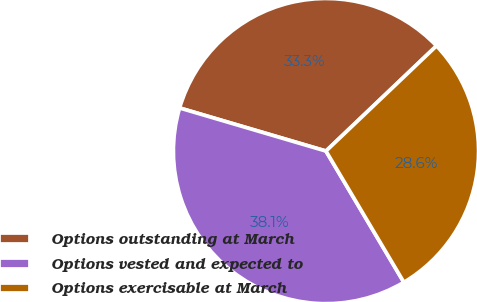Convert chart to OTSL. <chart><loc_0><loc_0><loc_500><loc_500><pie_chart><fcel>Options outstanding at March<fcel>Options vested and expected to<fcel>Options exercisable at March<nl><fcel>33.33%<fcel>38.08%<fcel>28.58%<nl></chart> 